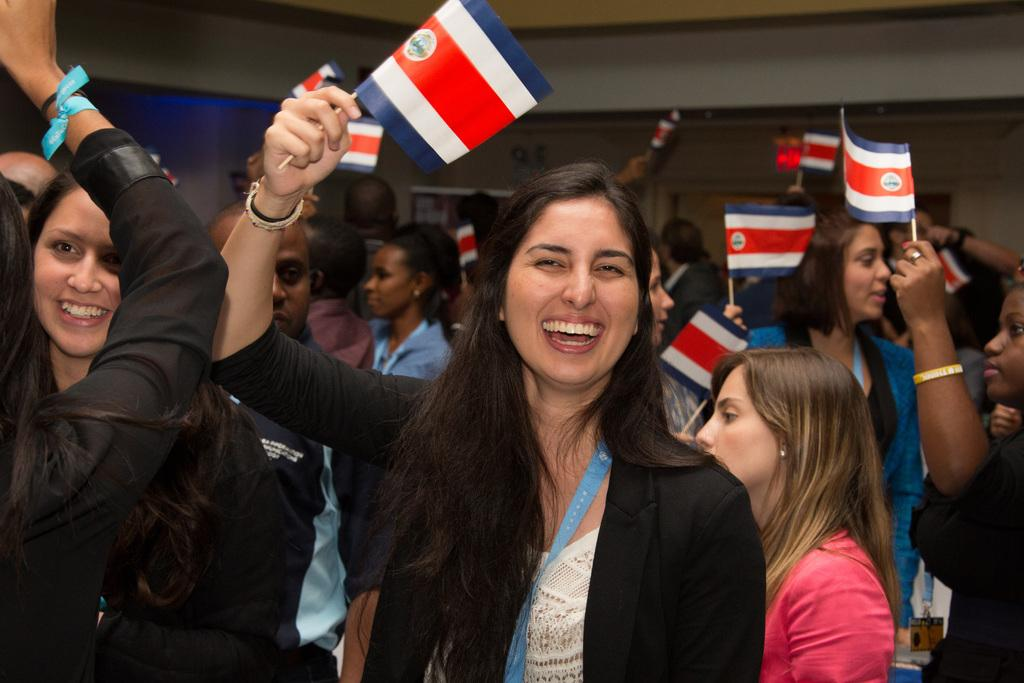What is happening in the image involving the group of people? The people in the image are smiling and holding flags in their hands. What can be seen in the background of the image? There is a wall in the background of the image. What type of friction can be observed between the people and the flags in the image? There is no friction present in the image; the people are holding the flags without any resistance or force. 